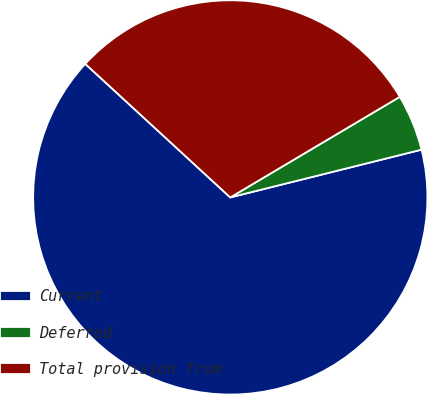Convert chart. <chart><loc_0><loc_0><loc_500><loc_500><pie_chart><fcel>Current<fcel>Deferred<fcel>Total provision from<nl><fcel>65.74%<fcel>4.63%<fcel>29.63%<nl></chart> 